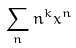Convert formula to latex. <formula><loc_0><loc_0><loc_500><loc_500>\sum _ { n } n ^ { k } x ^ { n }</formula> 